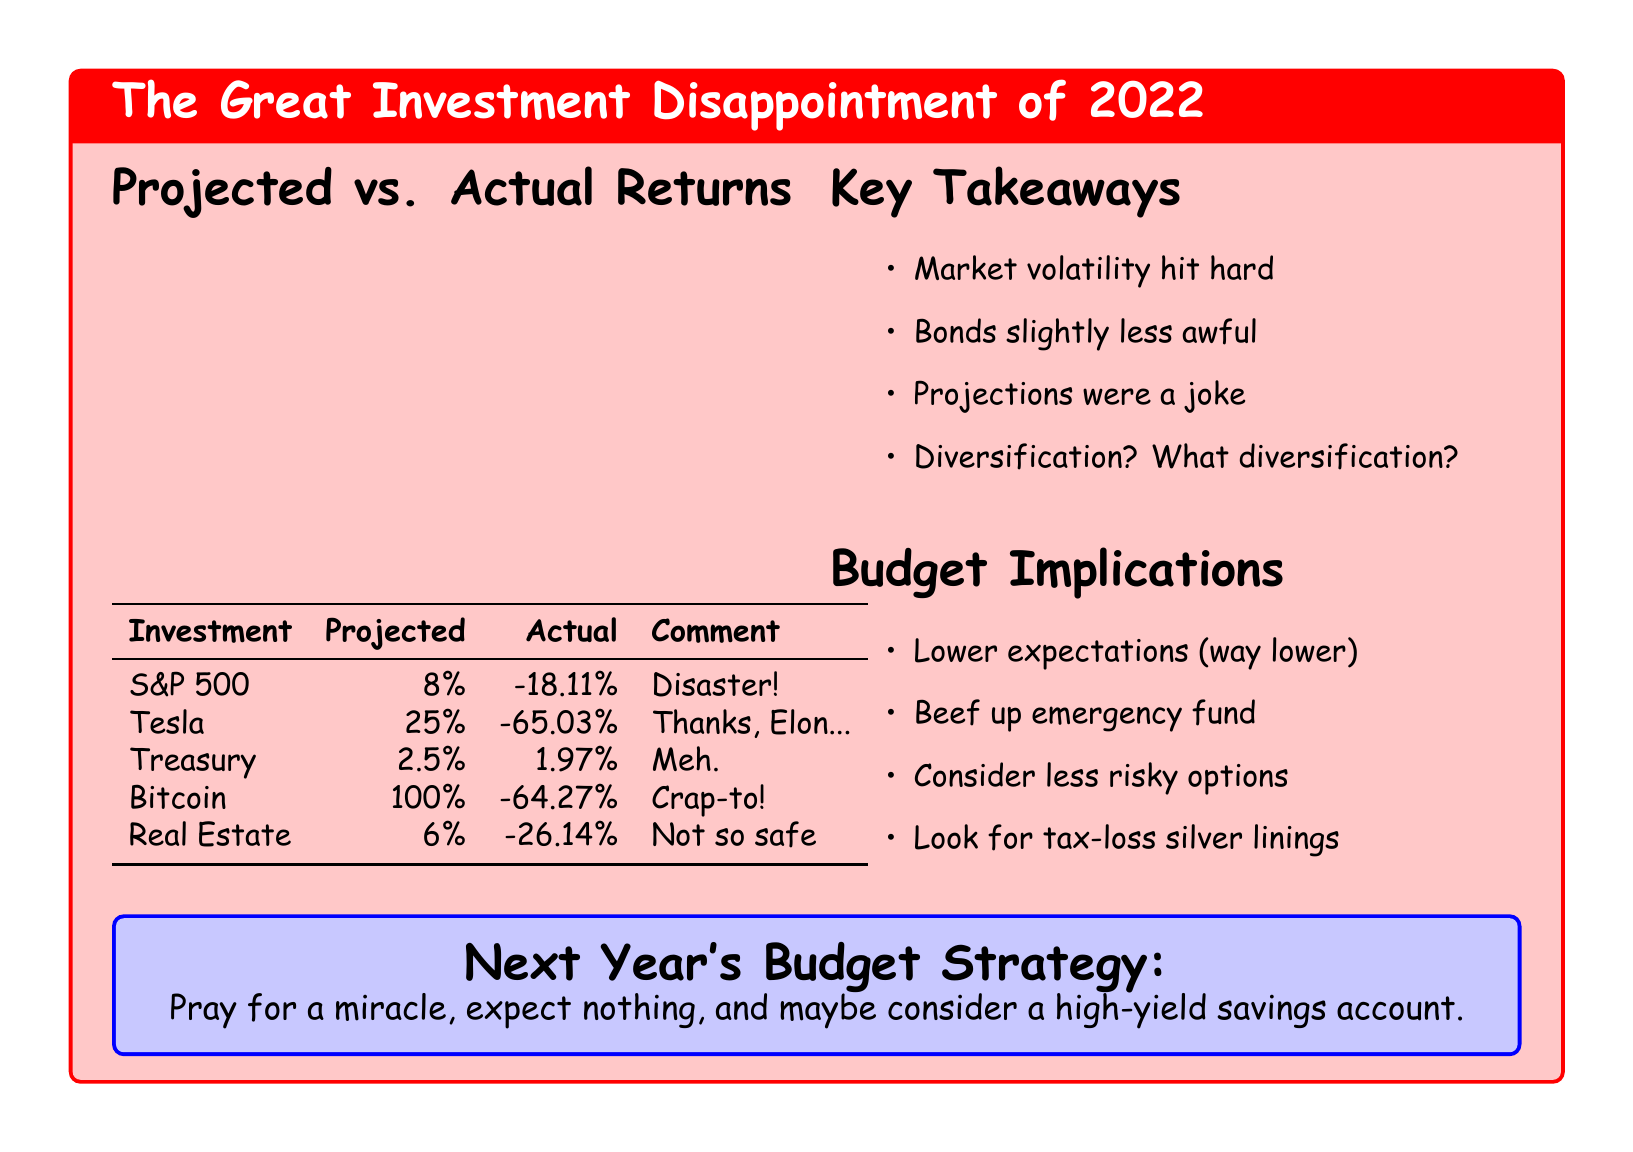What was the projected return for Tesla? The projected return is clearly stated in the table under the Tesla row, which is 25%.
Answer: 25% What was the actual return for Bitcoin? The actual return for Bitcoin is found in the table, listed as -64.27%.
Answer: -64.27% Which investment had the highest projected return? The investment with the highest projected return is Bitcoin, which had a projection of 100%.
Answer: 100% What was the comment for S&P 500? The comment for S&P 500 is a direct quote from the table stating "Disaster!".
Answer: Disaster! What are the key takeaways about market volatility? The document explicitly lists "Market volatility hit hard" as one of the key takeaways.
Answer: Market volatility hit hard How did actual returns compare to projected returns generally? The document indicates that projections were significantly off, summarized in the comment "Projections were a joke".
Answer: Projections were a joke What should investors consider doing according to the budget implications? One of the implications suggests to "Consider less risky options".
Answer: Consider less risky options What is recommended in the next year's budget strategy? The budget strategy implies to "Pray for a miracle, expect nothing".
Answer: Pray for a miracle, expect nothing What was the actual return on Treasury investments? The actual return on Treasury investments is provided in the table as 1.97%.
Answer: 1.97% 